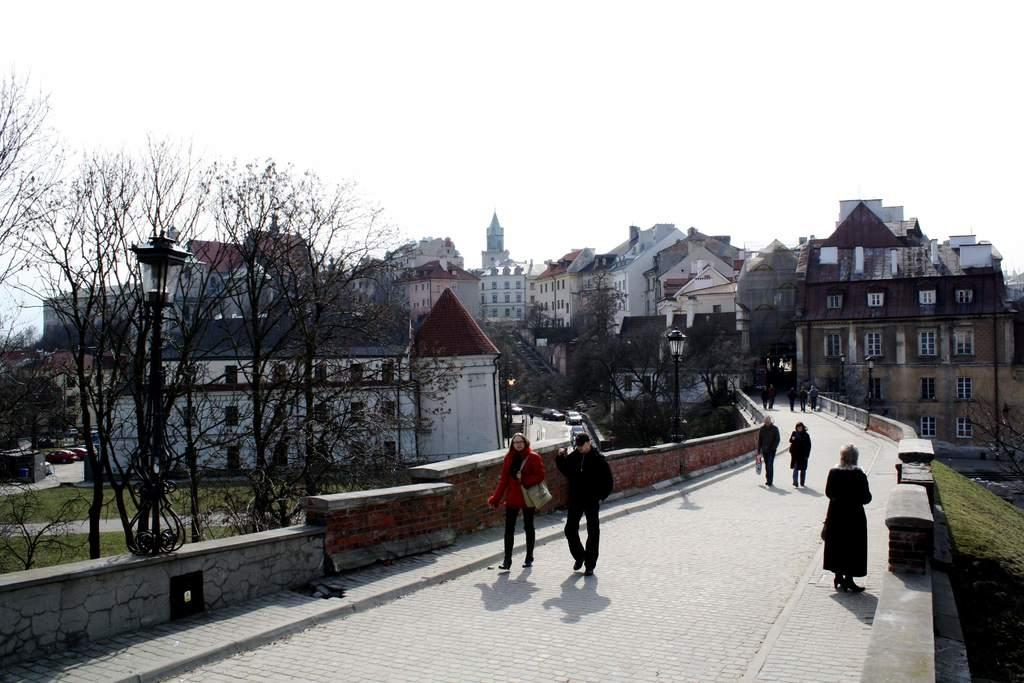What type of structures can be seen in the image? There are many houses and buildings in the image. What are the people in the image doing? There are people walking on a path on the right side of the image. What type of vegetation is present in the image? There are many trees in the image. What type of ground cover can be seen in the image? There is grass visible in the image. Where is the governor's cellar located in the image? There is no governor or cellar mentioned or visible in the image. How many passengers are in the image? There is no indication of passengers or any transportation vehicle in the image. 